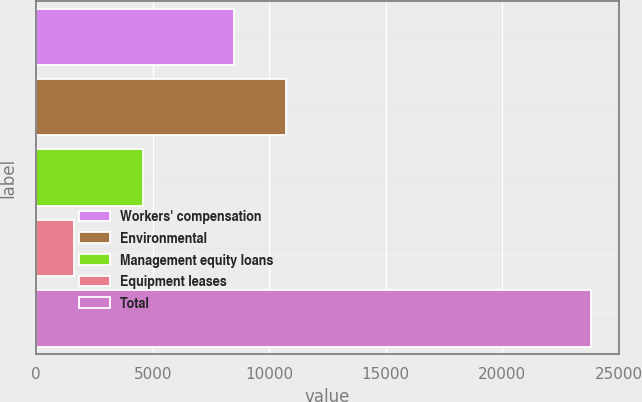<chart> <loc_0><loc_0><loc_500><loc_500><bar_chart><fcel>Workers' compensation<fcel>Environmental<fcel>Management equity loans<fcel>Equipment leases<fcel>Total<nl><fcel>8500<fcel>10717.9<fcel>4600<fcel>1643<fcel>23822<nl></chart> 